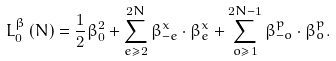Convert formula to latex. <formula><loc_0><loc_0><loc_500><loc_500>L _ { 0 } ^ { \beta } \left ( N \right ) = \frac { 1 } { 2 } \beta _ { 0 } ^ { 2 } + \sum _ { e \geq 2 } ^ { 2 N } \beta _ { - e } ^ { x } \cdot \beta _ { e } ^ { x } + \sum _ { o \geq 1 } ^ { 2 N - 1 } \beta _ { - o } ^ { p } \cdot \beta _ { o } ^ { p } .</formula> 